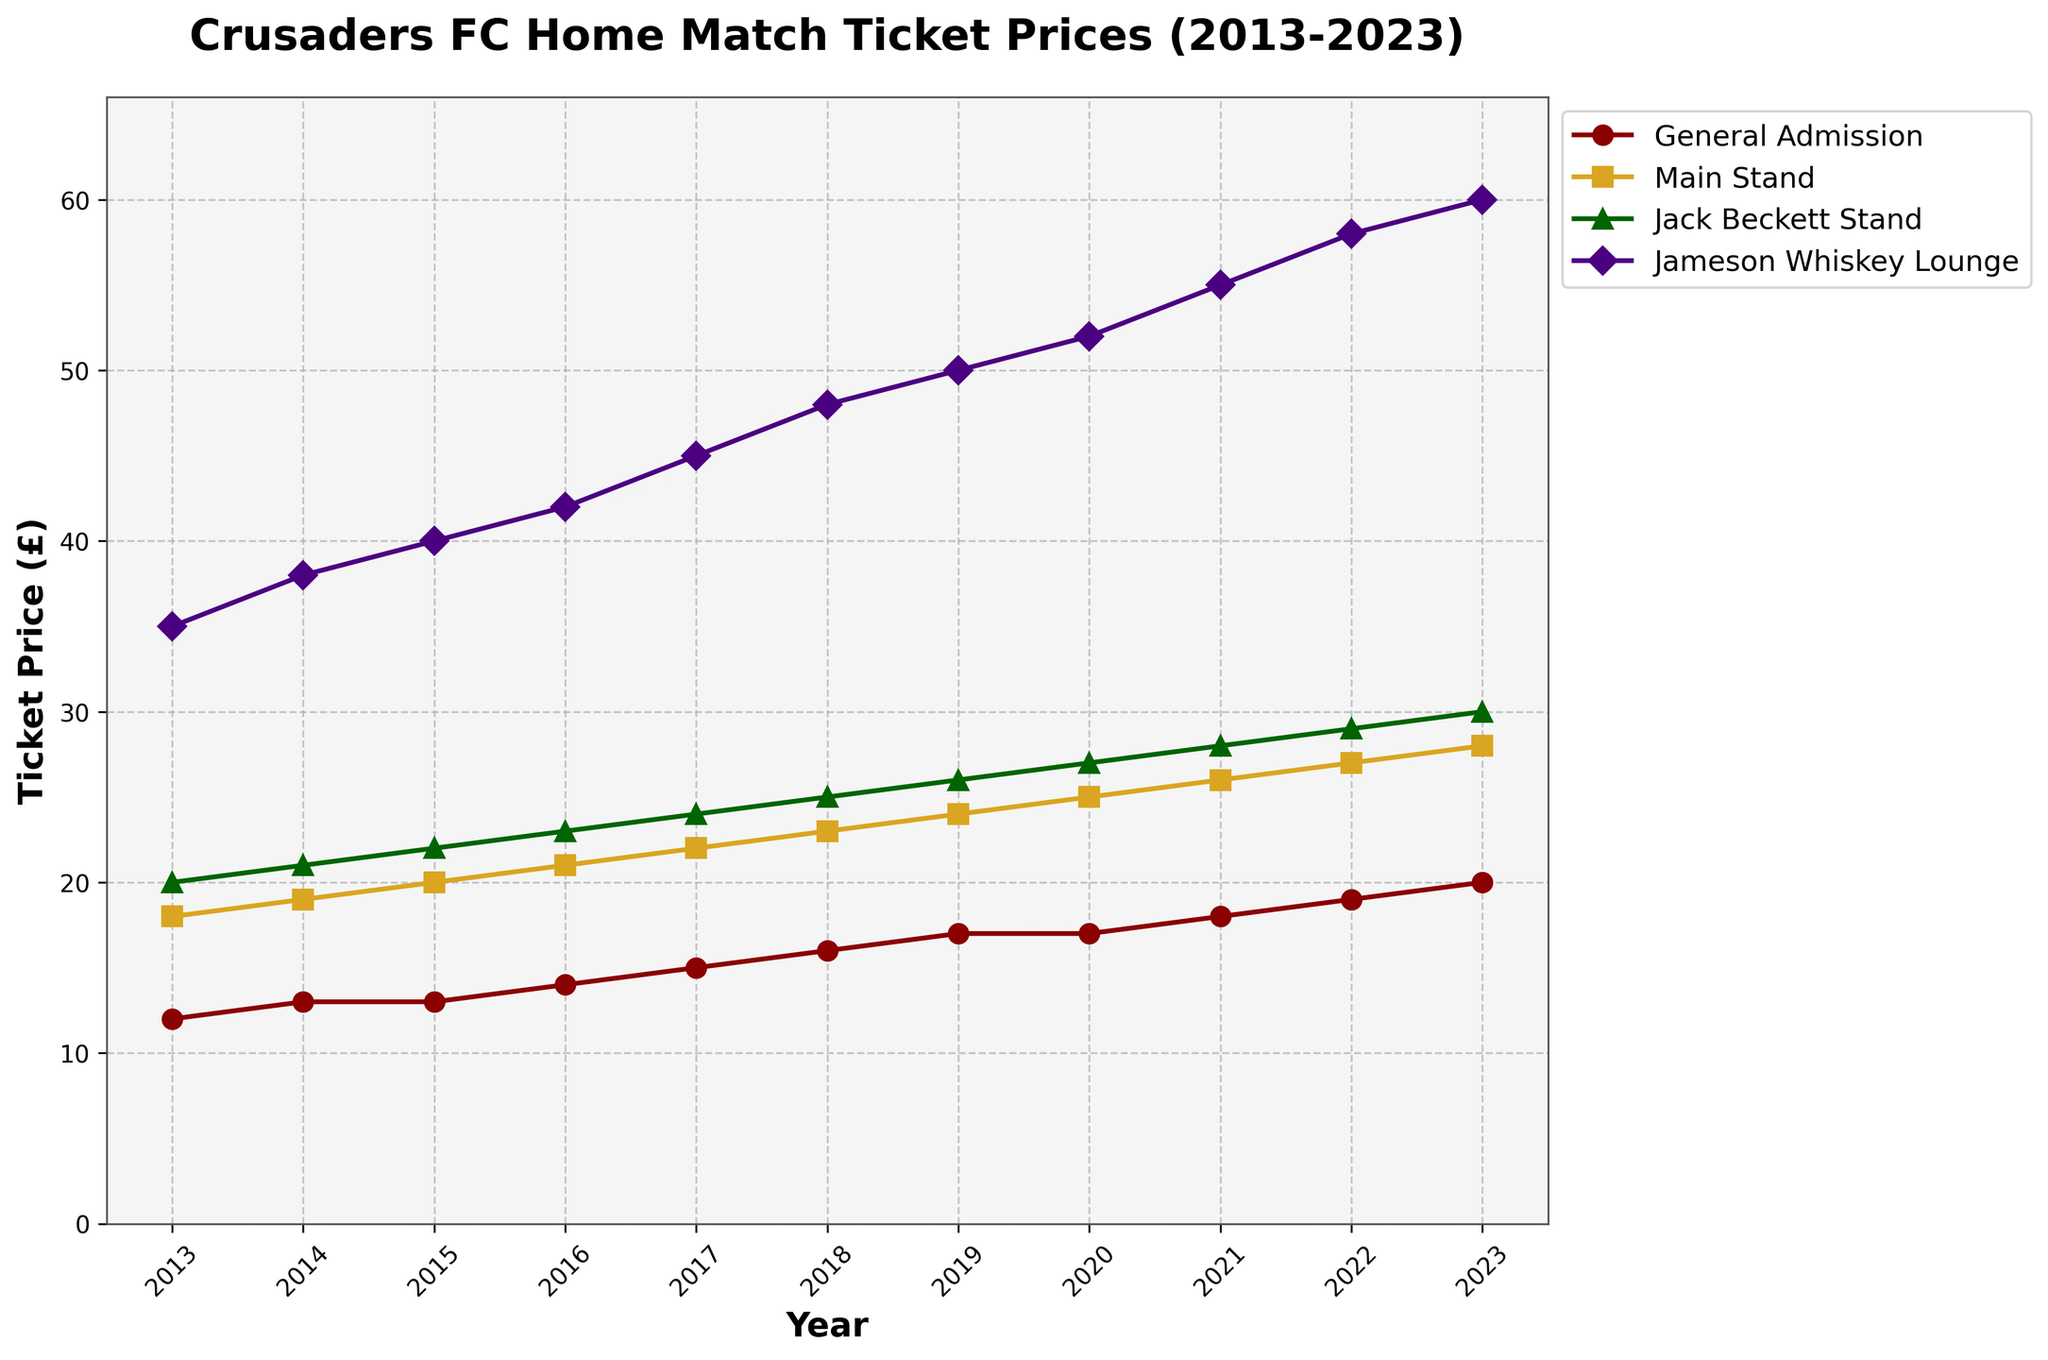What's the general trend of ticket prices for General Admission from 2013 to 2023? Observing the line for General Admission, the ticket prices have increased every year. In 2013, the price was £12, and by 2023, it has increased to £20. This shows a consistent upward trend.
Answer: Upward trend Between 2015 and 2020, which seating area saw the highest increase in ticket price? For each seating area, calculate the difference between 2020 and 2015 prices: General Admission increased by £4 (17-13), Main Stand by £5 (25-20), Jack Beckett Stand by £5 (27-22), Jameson Whiskey Lounge by £12 (52-40). The Jameson Whiskey Lounge saw the highest increase.
Answer: Jameson Whiskey Lounge In what year did the Jameson Whiskey Lounge ticket price reach £50 for the first time? Looking at the line for the Jameson Whiskey Lounge, the price reaches £50 in the year 2019.
Answer: 2019 Which seating area had the smallest price increase over the decade? Calculating the price difference from 2013 to 2023 for each seating area: General Admission increased by £8 (20-12), Main Stand by £10 (28-18), Jack Beckett Stand by £10 (30-20), Jameson Whiskey Lounge by £25 (60-35). General Admission had the smallest increase.
Answer: General Admission How much higher was the ticket price for Jameson Whiskey Lounge compared to the Main Stand in 2023? In 2023, the Jameson Whiskey Lounge ticket price was £60, and the Main Stand price was £28. The difference is £60 - £28 = £32.
Answer: £32 What has been the annual average increase in ticket prices for the Jack Beckett Stand? From 2013 to 2023, the increase in ticket price for the Jack Beckett Stand is £10 (30-20). Dividing by the number of years (2023-2013 = 10), the average annual increase is £1.
Answer: £1 Which year shows no increase in ticket prices for any seating area compared to the previous year? Comparing each year with the previous year, the year 2020 shows no increase in prices for General Admission. Other seating areas increased.
Answer: 2020 Compare the prices of General Admission and Jameson Whiskey Lounge in 2021. How much more expensive is the latter? In 2021, the General Admission price is £18, and the Jameson Whiskey Lounge price is £55. The difference is £55 - £18 = £37.
Answer: £37 In which year did the General Admission price see its highest yearly increase, and what was the amount? Analyzing yearly changes, the biggest increase for General Admission happened from 2021 to 2022, with the price going from £18 to £19, an increase of £1.
Answer: 2022, £1 